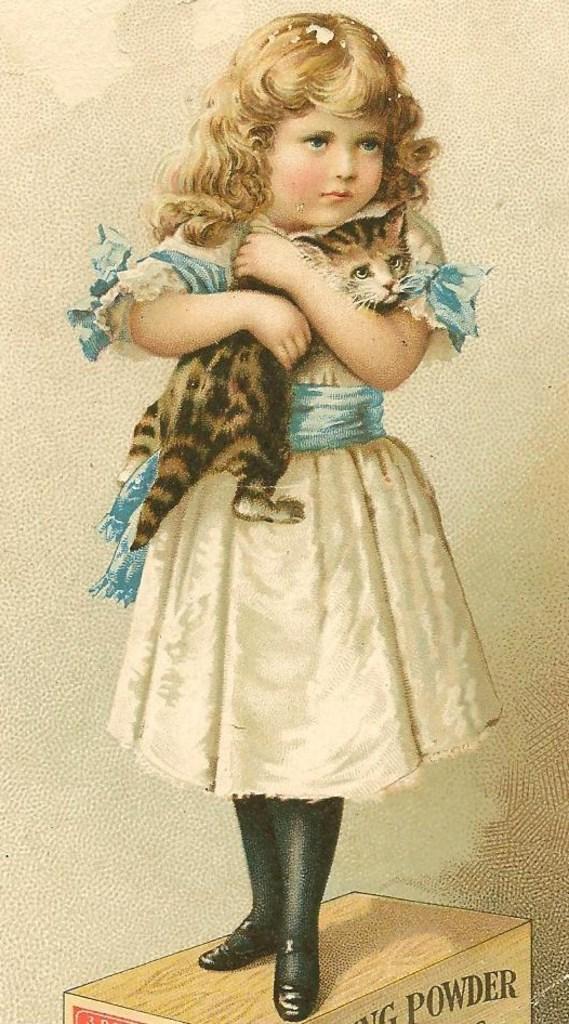In one or two sentences, can you explain what this image depicts? In this image, we can see a photo, in that photo we can see a girl standing on a wooden object and holding a cat. 